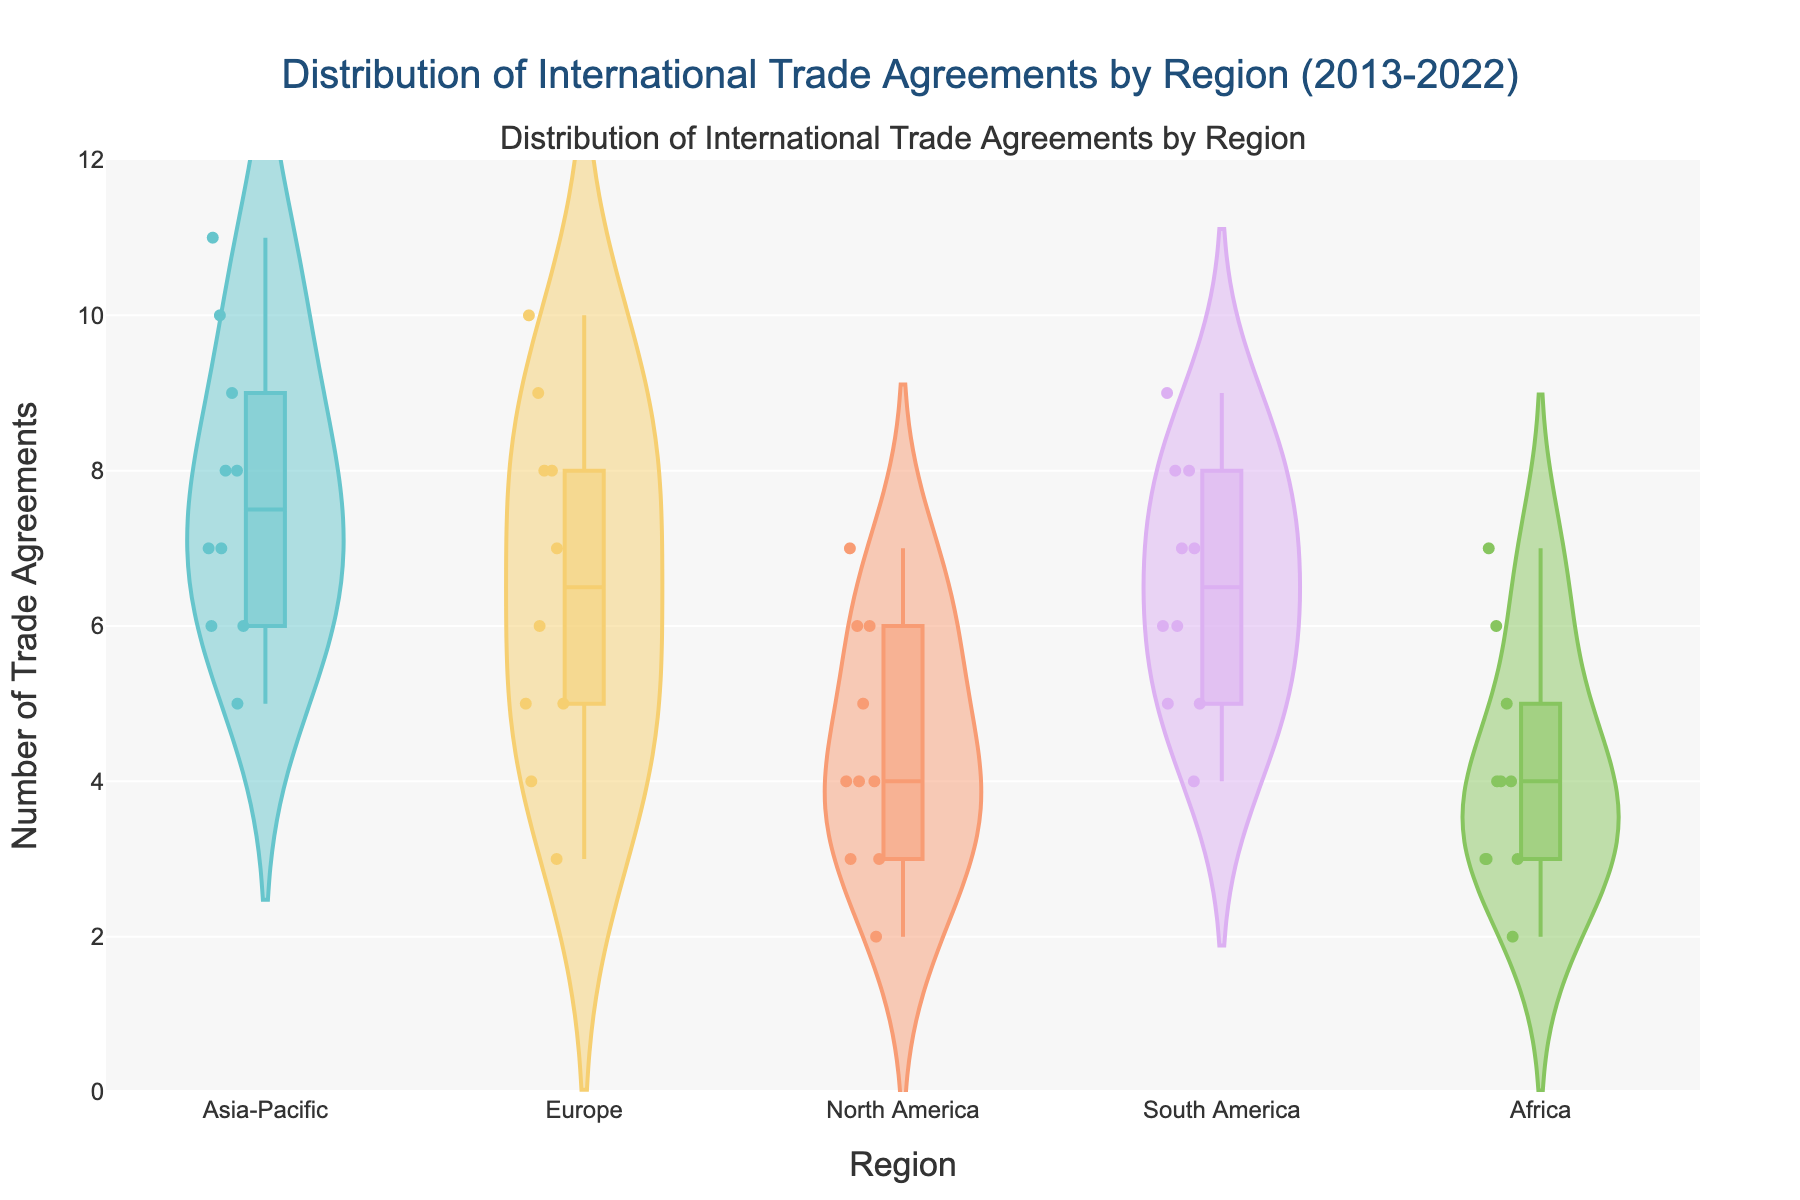what is the title of the figure? The title of the figure is displayed at the top of the chart. It is written in a larger font size than the rest and centered.
Answer: Distribution of International Trade Agreements by Region (2013-2022) Which region has the highest peak in the distribution of trade agreements? By observing the density of the data points and the range of the y-axis, you can identify the region with the highest peaks.
Answer: Asia-Pacific How many total trade agreements were made by Europe from 2013 to 2022? Sum the number of trade agreements made by Europe for each year from the data points in the figure.
Answer: 65 Which region has the smallest spread in the number of trade agreements? The region with the smallest spread will have data points clustered more closely together, producing a narrower violin plot.
Answer: North America What is the range of trade agreements in Africa? Observe the minimum and maximum data points within Africa's violin plot to determine the range.
Answer: 2 to 7 Compare the median number of trade agreements between Europe and South America. Which has a higher median? By identifying the central points of the violin plots for both regions, you can compare their medians.
Answer: Europe What was the highest number of trade agreements in North America throughout the decade? Identify the peak point in the violin plot for North America to determine the maximum value.
Answer: 7 Which region has a more consistent number of trade agreements across the years, Africa or Asia-Pacific? Consistency can be observed from the violin plots. A more consistent region will have a tighter clustering of data points.
Answer: Africa What is the interquartile range (IQR) of trade agreements in South America? The IQR is the range between the first quartile (25th percentile) and the third quartile (75th percentile) within the violin plot for South America.
Answer: Approximately 6 to 8 